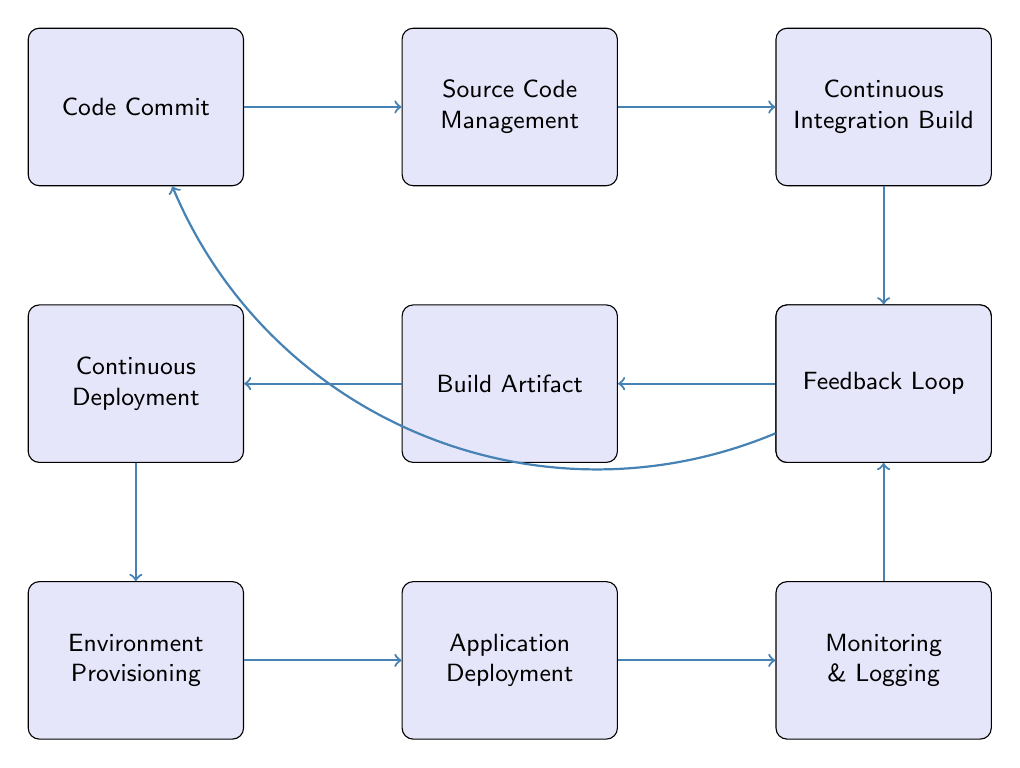What is the first step in the CI/CD pipeline? The first step in the diagram is labeled "Code Commit," which indicates that developers start by committing their code to the source repository.
Answer: Code Commit How many total nodes are present in the diagram? Counting each labeled box in the diagram, there are ten distinct nodes representing various stages in the CI/CD pipeline.
Answer: Ten What happens after the "Continuous Integration Build"? Following the "Continuous Integration Build," the next step is "Automated Tests," which indicates that tests are run to validate the code changes made.
Answer: Automated Tests What is produced as a result of the "Build Artifact" node? The "Build Artifact" node indicates the outcome is generation of build artifacts, which are essential components ready for deployment.
Answer: Build artifacts Which node provides feedback to developers? The "Feedback Loop" node is specifically designed to gather feedback and communicate back to developers, ensuring they are informed about the deployment process.
Answer: Feedback Loop What is the purpose of the "Environment Provisioning" step? "Environment Provisioning" involves setting up the necessary environments for application deployment, utilizing Infrastructure as Code tools like Terraform or Ansible.
Answer: Set up environments Which node follows "Continuous Deployment" in the flow? The node that directly follows "Continuous Deployment" is "Environment Provisioning," indicating that deployment leads to the preparation of environments for the applications.
Answer: Environment Provisioning Describe the connection between "Monitoring & Logging" and "Feedback Loop." "Monitoring & Logging" feeds into the "Feedback Loop," which suggests that application performance monitoring and log data are used to provide feedback to developers for continuous improvement.
Answer: It provides feedback What tools might be used during the "Automated Tests" phase? The "Automated Tests" phase references tools such as JUnit, TestNG, or Selenium that are commonly used to validate code changes through testing.
Answer: JUnit, TestNG, Selenium Which step signifies the end of the CI/CD pipeline? The last step in the pipeline is "Feedback Loop," which marks the return of insights and suggestions to developers, completing the process.
Answer: Feedback Loop 